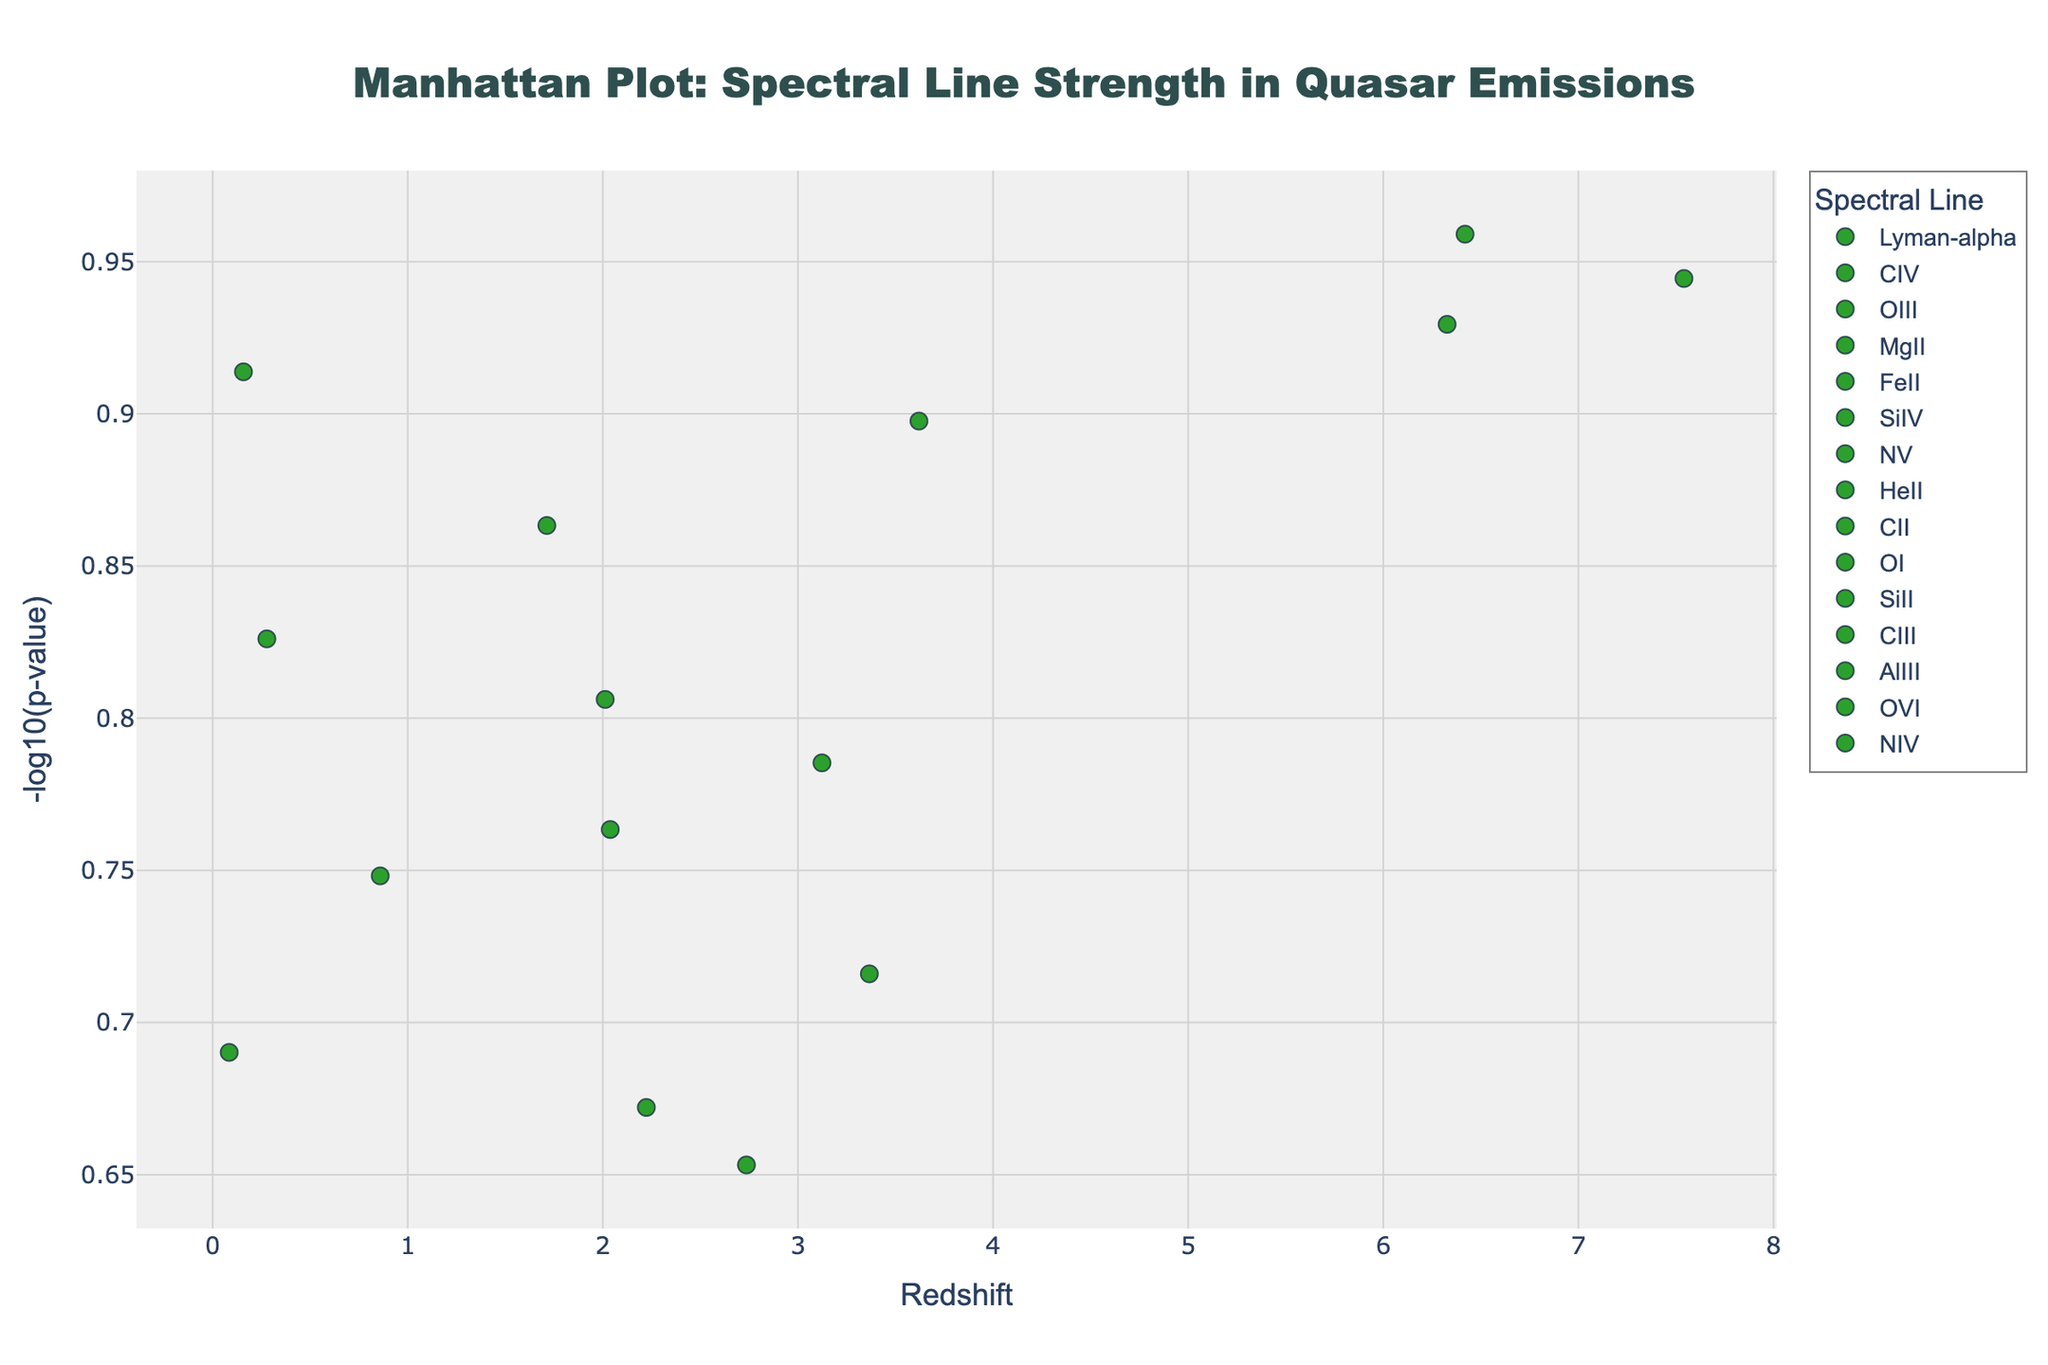What is the title of the plot? The title of the plot is prominently displayed at the top of the figure. It reads "Manhattan Plot: Spectral Line Strength in Quasar Emissions".
Answer: Manhattan Plot: Spectral Line Strength in Quasar Emissions Which spectral line has the highest -log10(p-value) and at what redshift? By scanning the y-axis for the highest point and checking the corresponding x-axis and marker label, we see the spectral line with the highest -log10(p-value) is MgII, at a redshift of 6.419.
Answer: MgII at redshift 6.419 What spectral line is found at the redshift 7.541, and what is its -log10(p-value)? By locating the point on the x-axis at 7.541 and identifying the associated marker and y-value, we find that the spectral line is CII and its -log10(p-value) is approximately 0.94.
Answer: CII with -log10(p-value) around 0.94 How many data points have a -log10(p-value) greater than 1? Count the points above the y-value of 1. There are four such points: one for MgII, one for CII, one for OVI, and one for Lyman-alpha.
Answer: 4 Which quasar corresponds to the spectral line CIII and what is its -log10(p-value)? By checking the legend for CIII and cross-referencing the markers, we see that the quasar Q1422+2309 corresponds to CIII with a -log10(p-value) of about 0.9.
Answer: Q1422+2309 with -log10(p-value) around 0.9 Compare the -log10(p-value) of the quasars located at redshift 2.736 and 1.713. Which one has a higher value and by how much? Locate the points at redshifts 2.736 and 1.713 on the x-axis and compare their y-values. The quasar at redshift 2.736 (HeII) has a -log10(p-value) of about 0.653, and the one at redshift 1.713 (SiIV) has a -log10(p-value) of about 0.859. Thus, SiIV's -log10(p-value) is higher by 0.206.
Answer: SiIV is higher by 0.206 Which spectral line is represented across the largest range of redshifts? Inspect the markers for each spectral line and note where their points fall on the x-axis. CIV is observed at both 0.278 and 2.012, representing the largest range.
Answer: CIV Are there any redshifts with multiple spectral lines? If yes, name them and the corresponding lines. Scan the plot for any vertical alignment of points. There are no redshifts with multiple spectral lines indicated.
Answer: No What is the -log10(p-value) trend as the redshift increases? Observe the trend of the points moving from left to right. While there is some variability, there is no clear increasing or decreasing trend for the -log10(p-value) as redshift increases.
Answer: No clear trend Which spectral lines show strong signals (i.e., high -log10(p-value)) at lower redshifts? Examine the plot for points with high y-values at lower x-values. Lyman-alpha at redshift 0.158 and OIII at redshift 0.085 show strong signals.
Answer: Lyman-alpha and OIII 